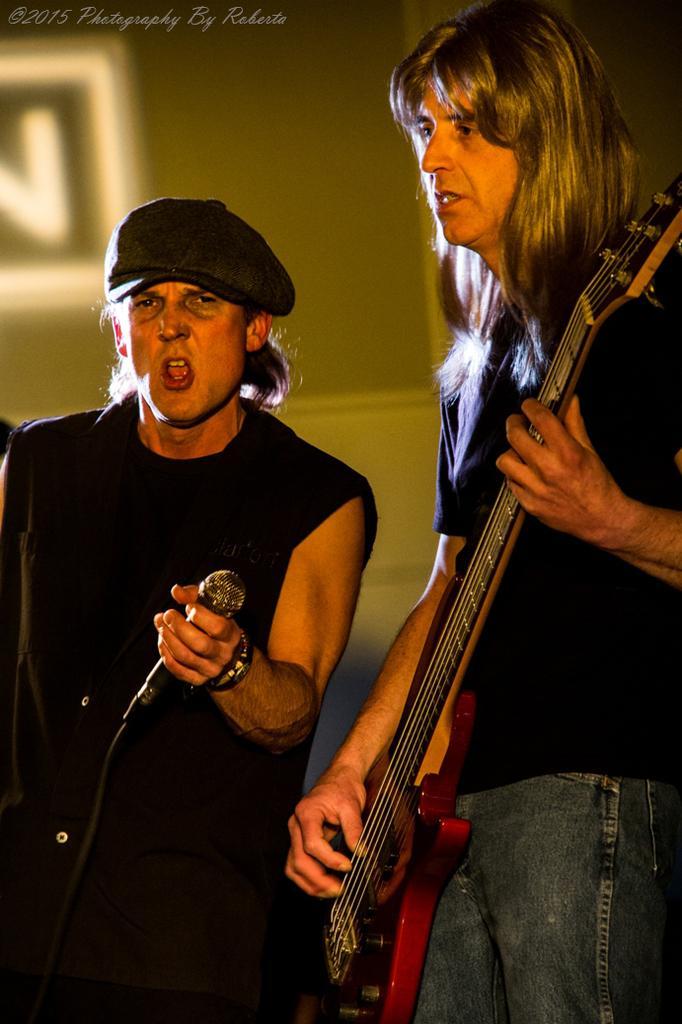How would you summarize this image in a sentence or two? In this picture we can see two persons holding a guitar and a microphone. The person who held the microphone is singing. 